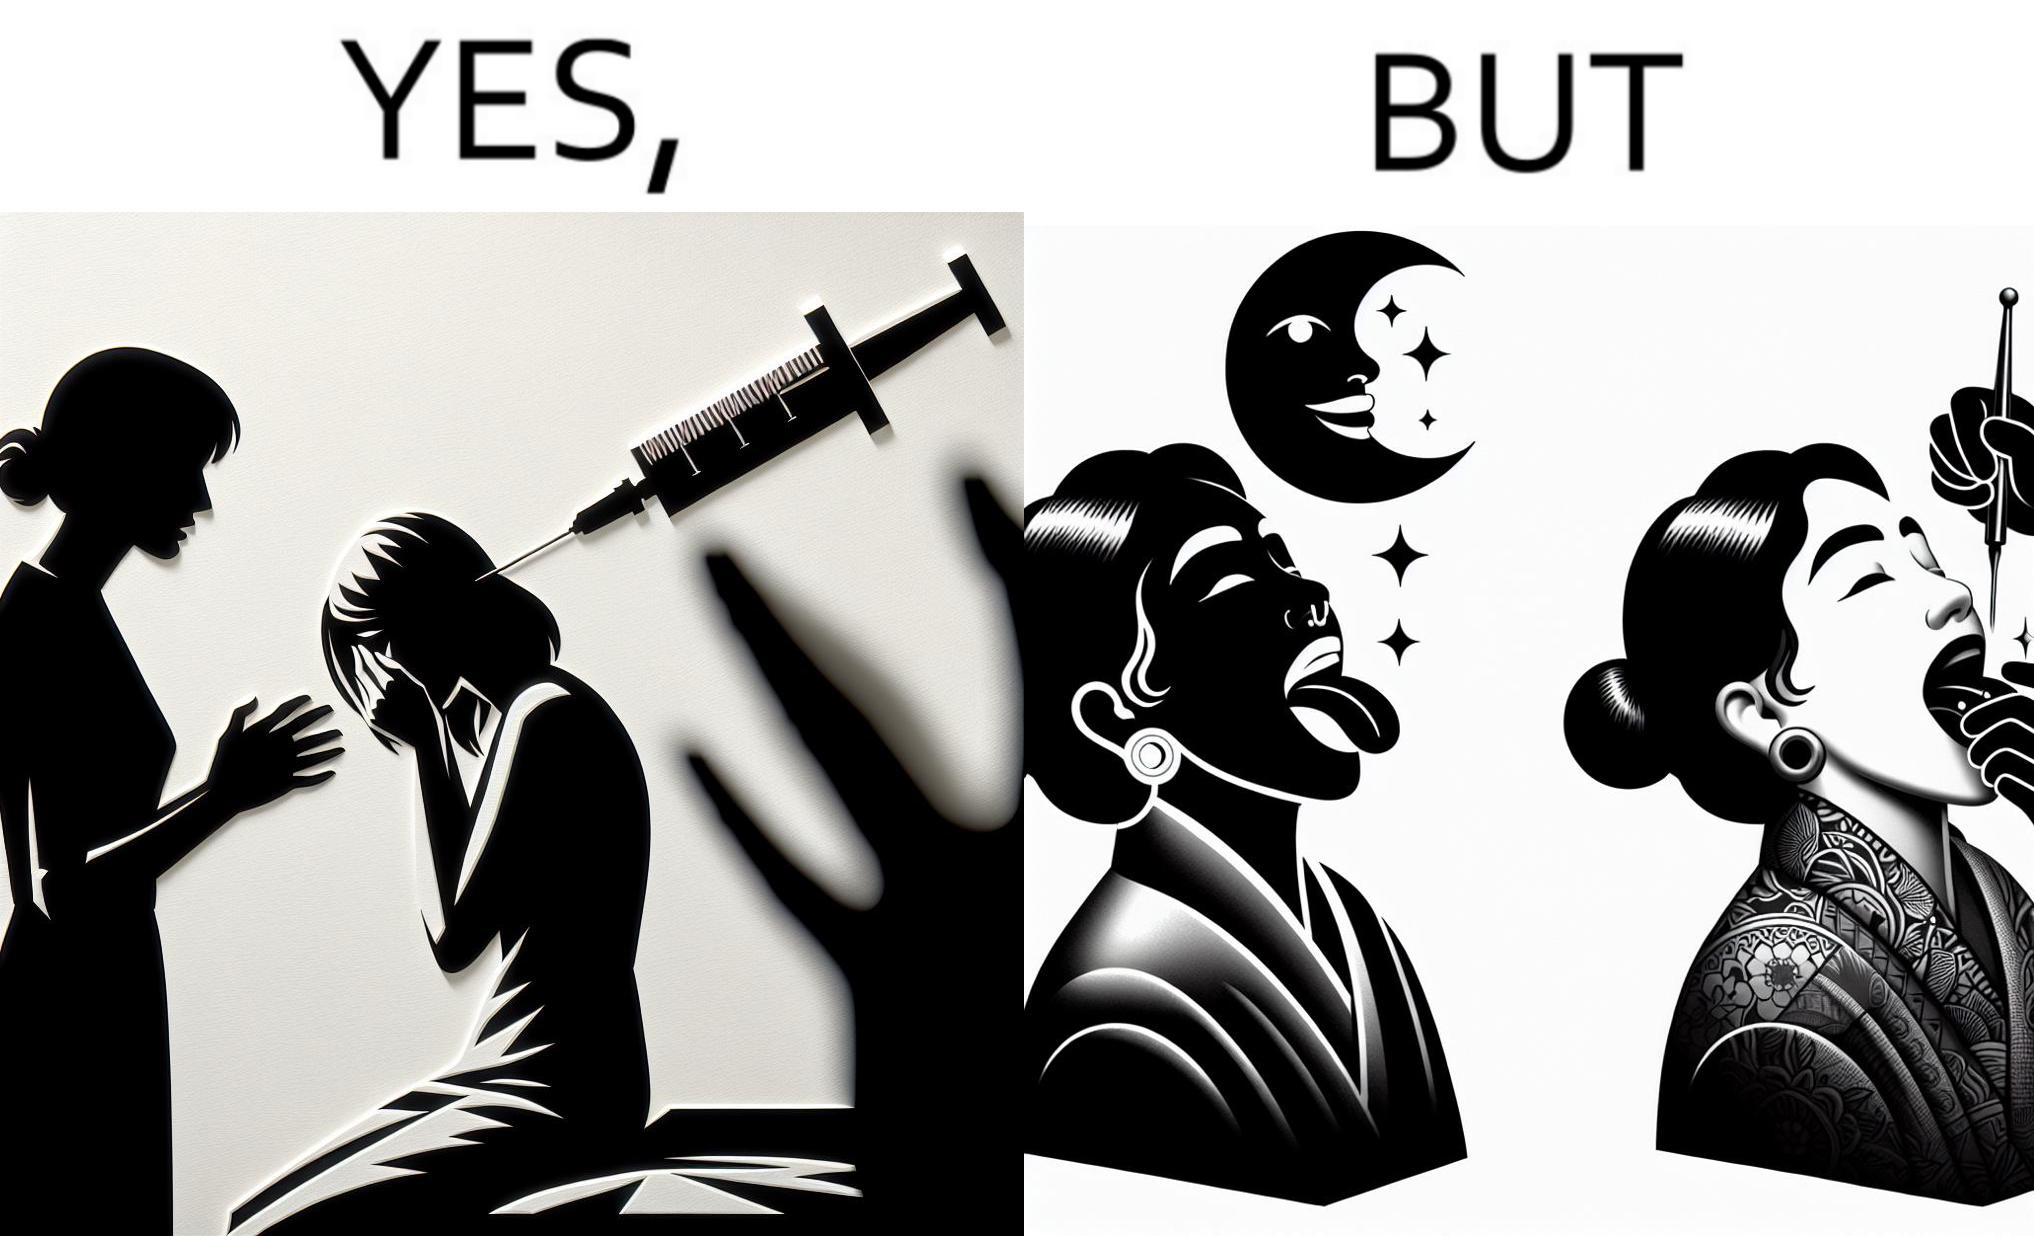Describe the contrast between the left and right parts of this image. In the left part of the image: The iamge shows a woman scared of the syringe about to be used to inject her with medicine. In the right part of the image: The image shows a woman with her tongue out getting a piercing in her tongue. The image also shows shows the same woman getting tattoed on her left arm at the same time as getting  a piercing. 